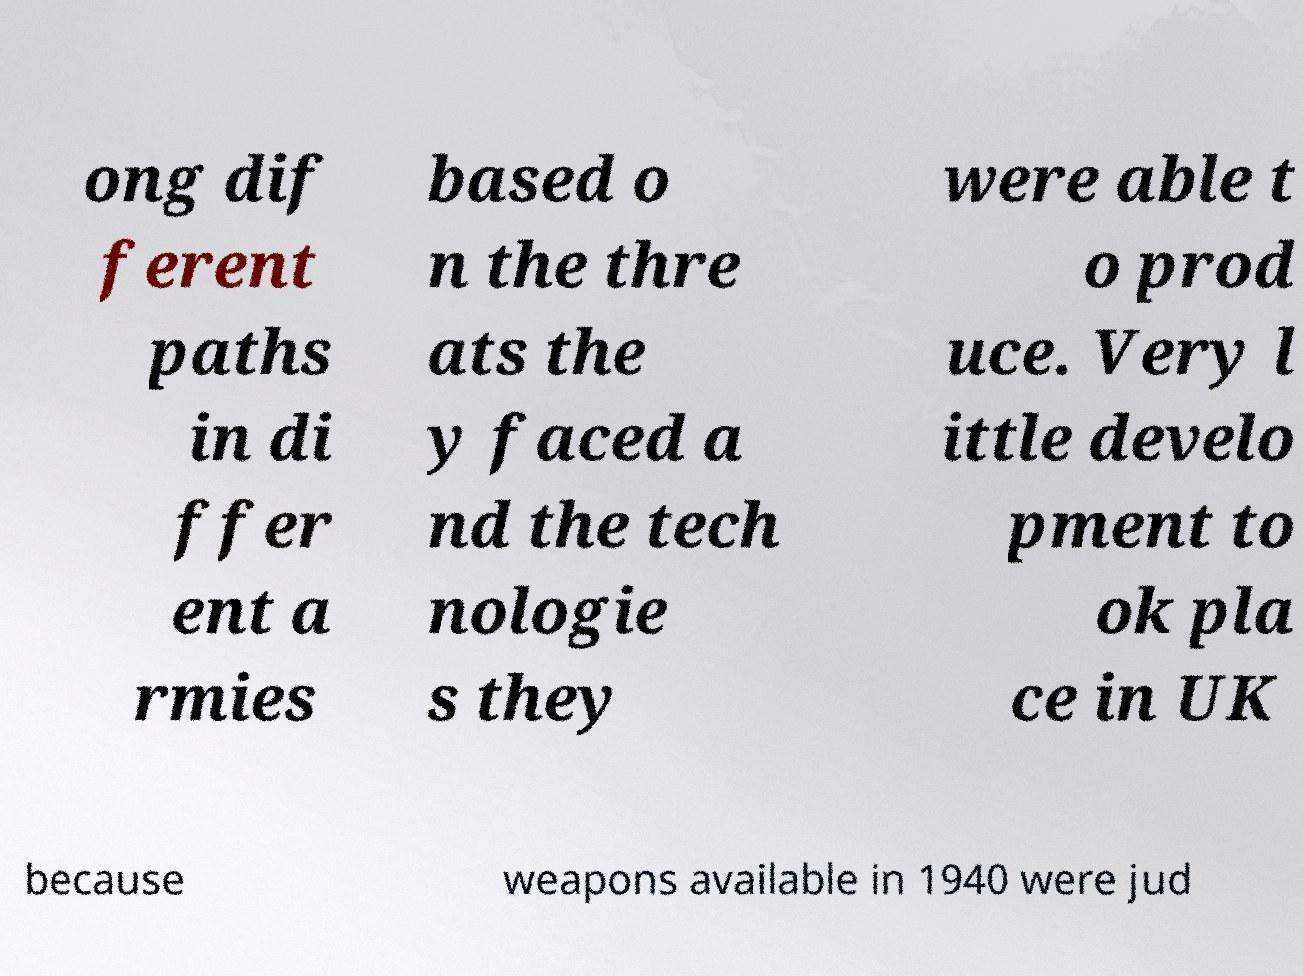What messages or text are displayed in this image? I need them in a readable, typed format. ong dif ferent paths in di ffer ent a rmies based o n the thre ats the y faced a nd the tech nologie s they were able t o prod uce. Very l ittle develo pment to ok pla ce in UK because weapons available in 1940 were jud 